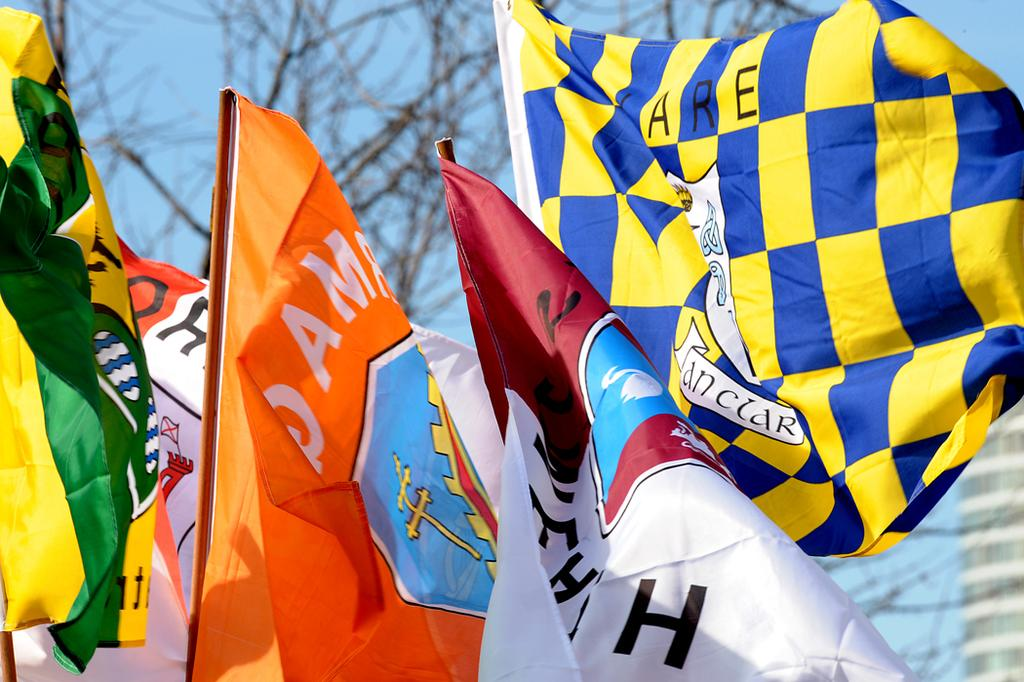What objects are on poles in the image? There are flags on poles in the image. How would you describe the background of the image? The background of the image is slightly blurred. What type of natural elements can be seen in the background? Trees are visible in the background of the image. What color is the sky in the image? The sky is pale blue in color. How many sisters are depicted in the image? There are no sisters present in the image; it features flags on poles, a blurred background, trees, and a pale blue sky. What type of knowledge is being shared in the image? There is no knowledge being shared in the image; it is a visual representation of flags on poles, a blurred background, trees, and a pale blue sky. 